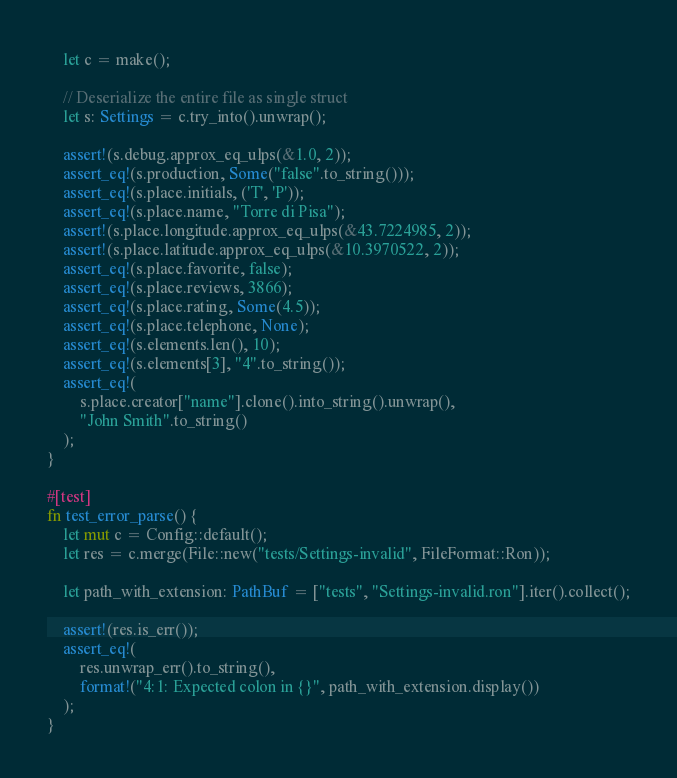Convert code to text. <code><loc_0><loc_0><loc_500><loc_500><_Rust_>    let c = make();

    // Deserialize the entire file as single struct
    let s: Settings = c.try_into().unwrap();

    assert!(s.debug.approx_eq_ulps(&1.0, 2));
    assert_eq!(s.production, Some("false".to_string()));
    assert_eq!(s.place.initials, ('T', 'P'));
    assert_eq!(s.place.name, "Torre di Pisa");
    assert!(s.place.longitude.approx_eq_ulps(&43.7224985, 2));
    assert!(s.place.latitude.approx_eq_ulps(&10.3970522, 2));
    assert_eq!(s.place.favorite, false);
    assert_eq!(s.place.reviews, 3866);
    assert_eq!(s.place.rating, Some(4.5));
    assert_eq!(s.place.telephone, None);
    assert_eq!(s.elements.len(), 10);
    assert_eq!(s.elements[3], "4".to_string());
    assert_eq!(
        s.place.creator["name"].clone().into_string().unwrap(),
        "John Smith".to_string()
    );
}

#[test]
fn test_error_parse() {
    let mut c = Config::default();
    let res = c.merge(File::new("tests/Settings-invalid", FileFormat::Ron));

    let path_with_extension: PathBuf = ["tests", "Settings-invalid.ron"].iter().collect();

    assert!(res.is_err());
    assert_eq!(
        res.unwrap_err().to_string(),
        format!("4:1: Expected colon in {}", path_with_extension.display())
    );
}
</code> 